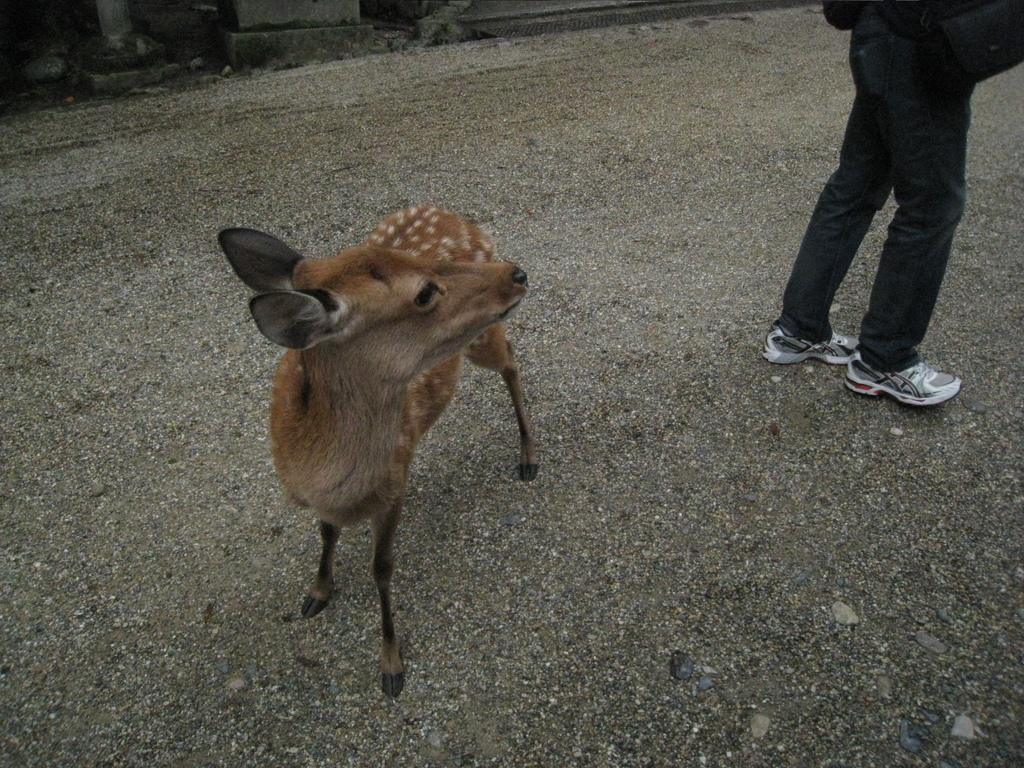What type of animal is in the image? There is an animal in the image, but the specific type cannot be determined from the provided facts. Who or what else is in the image? There is a person in the image, along with the animal. Where are the animal and person located in the image? Both the animal and person are on the ground in the image. What can be seen in the background of the image? There is a fence and stones in the background of the image. Can you tell if the image was taken during the day or night? The image was likely taken during the day, as there is no mention of darkness or nighttime in the provided facts. What letters are being written by the animal in the image? There are no letters or writing present in the image, as it features an animal and a person on the ground with a fence and stones in the background. 